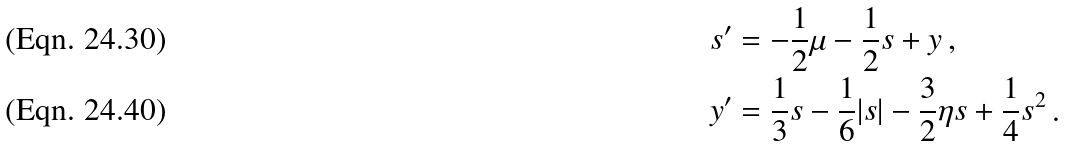Convert formula to latex. <formula><loc_0><loc_0><loc_500><loc_500>s ^ { \prime } & = - \frac { 1 } { 2 } \mu - \frac { 1 } { 2 } s + y \, , \\ y ^ { \prime } & = \frac { 1 } { 3 } s - \frac { 1 } { 6 } | s | - \frac { 3 } { 2 } \eta s + \frac { 1 } { 4 } s ^ { 2 } \, .</formula> 